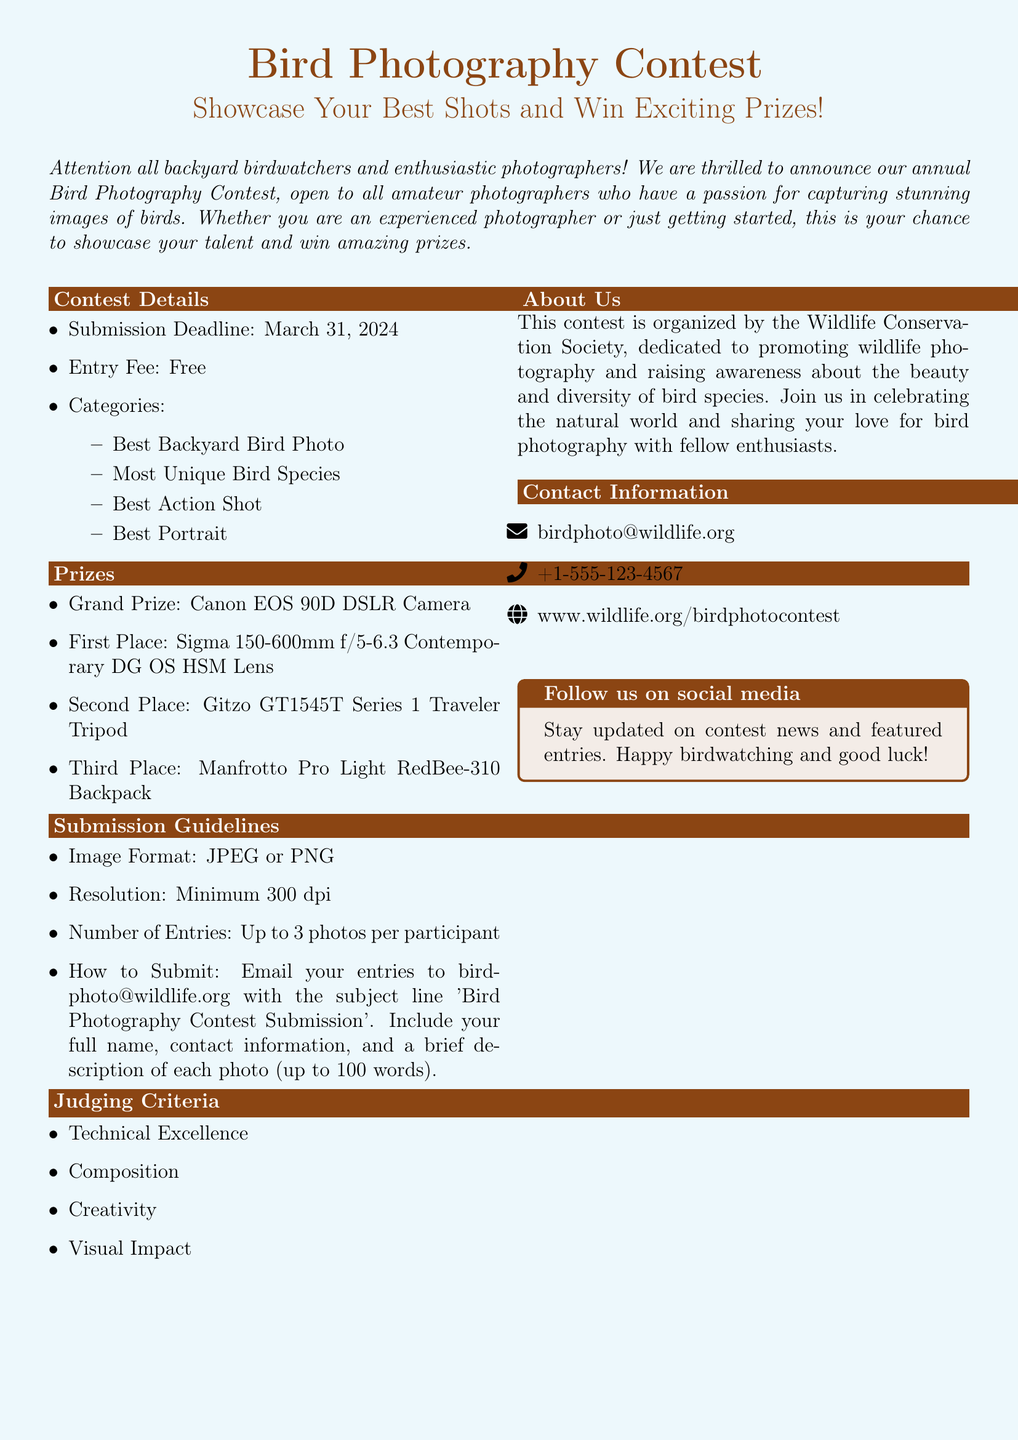What is the submission deadline for the contest? The submission deadline is specified in the contest details section of the document.
Answer: March 31, 2024 What is the entry fee for the contest? The entry fee is mentioned as a specific amount in the contest details section.
Answer: Free How many categories are there in the contest? The number of categories is indicated in the contest details section.
Answer: Four What is the grand prize for the contest? The grand prize is listed under the prizes section of the document.
Answer: Canon EOS 90D DSLR Camera What is the image resolution requirement? The resolution requirement is stated in the submission guidelines section of the document.
Answer: Minimum 300 dpi What is the maximum number of entries allowed per participant? The maximum number of entries allowed is specified in the submission guidelines section.
Answer: Up to 3 photos What are the judging criteria for the contest? The judging criteria are outlined in the document and include specific factors.
Answer: Technical Excellence, Composition, Creativity, Visual Impact Who is organizing the contest? The organizer of the contest is mentioned in the about us section in the document.
Answer: Wildlife Conservation Society What should the subject line be for submission emails? The required subject line for submission emails is stated in the submission guidelines section.
Answer: Bird Photography Contest Submission 